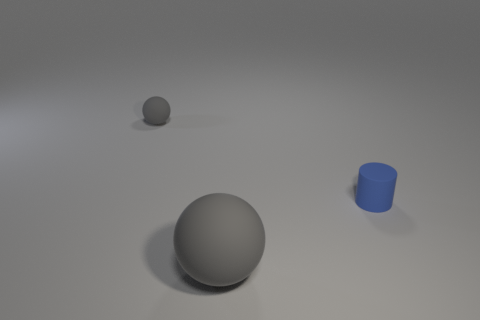Subtract all red cylinders. Subtract all cyan balls. How many cylinders are left? 1 Add 2 small metallic balls. How many objects exist? 5 Subtract all cylinders. How many objects are left? 2 Add 1 tiny rubber balls. How many tiny rubber balls are left? 2 Add 1 large blue cubes. How many large blue cubes exist? 1 Subtract 0 cyan cubes. How many objects are left? 3 Subtract all blue cylinders. Subtract all tiny gray rubber cylinders. How many objects are left? 2 